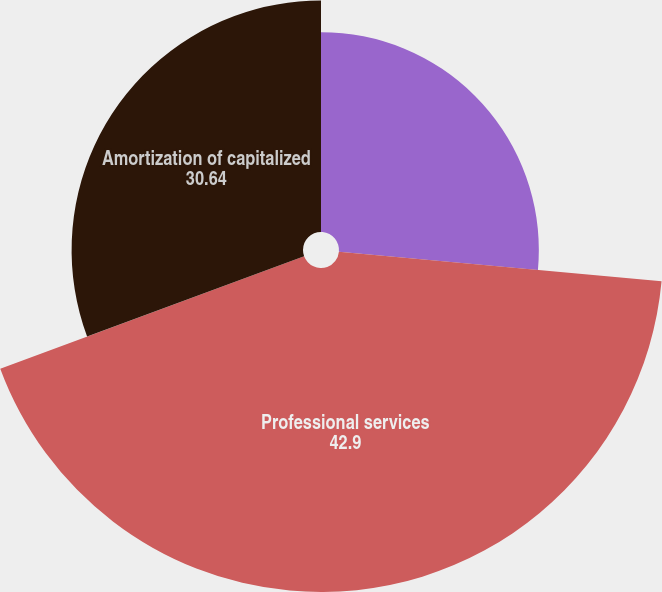Convert chart to OTSL. <chart><loc_0><loc_0><loc_500><loc_500><pie_chart><fcel>Bank owned life insurance<fcel>Professional services<fcel>Amortization of capitalized<nl><fcel>26.46%<fcel>42.9%<fcel>30.64%<nl></chart> 